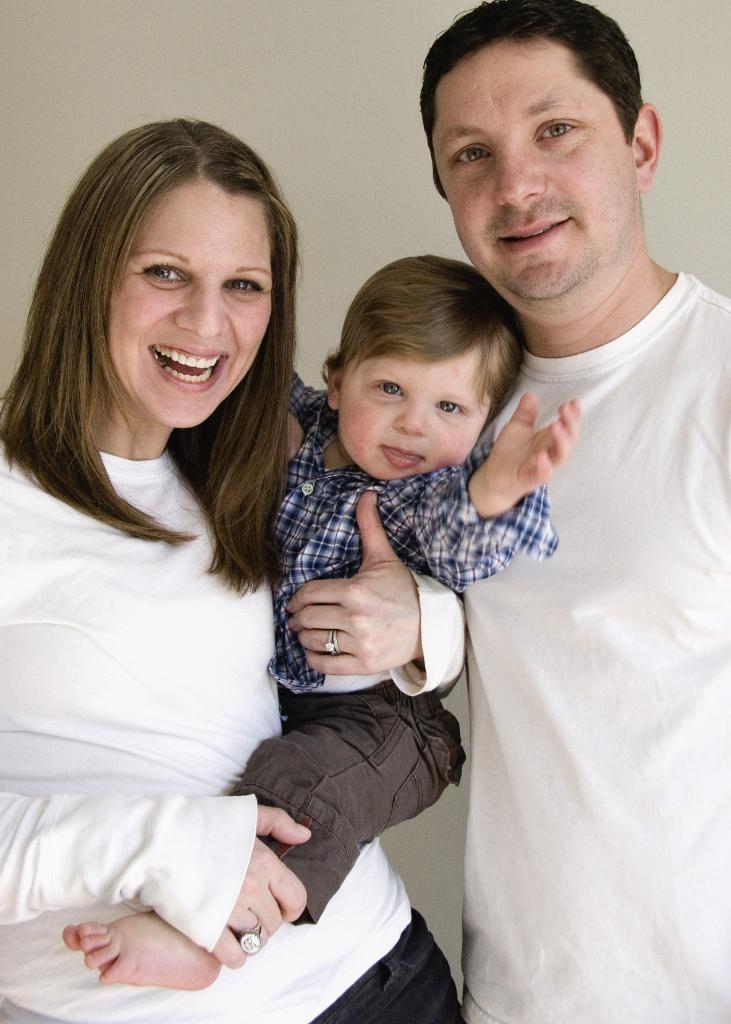Who is present in the image? There is a couple and a child in the image. What are the couple and the child doing? The couple and the child are standing together and smiling. What can be seen behind the couple and the child? There is a wall behind them. What type of cream is being used to paint the wall in the image? There is no cream or painting activity present in the image; it features a couple, a child, and a wall. 